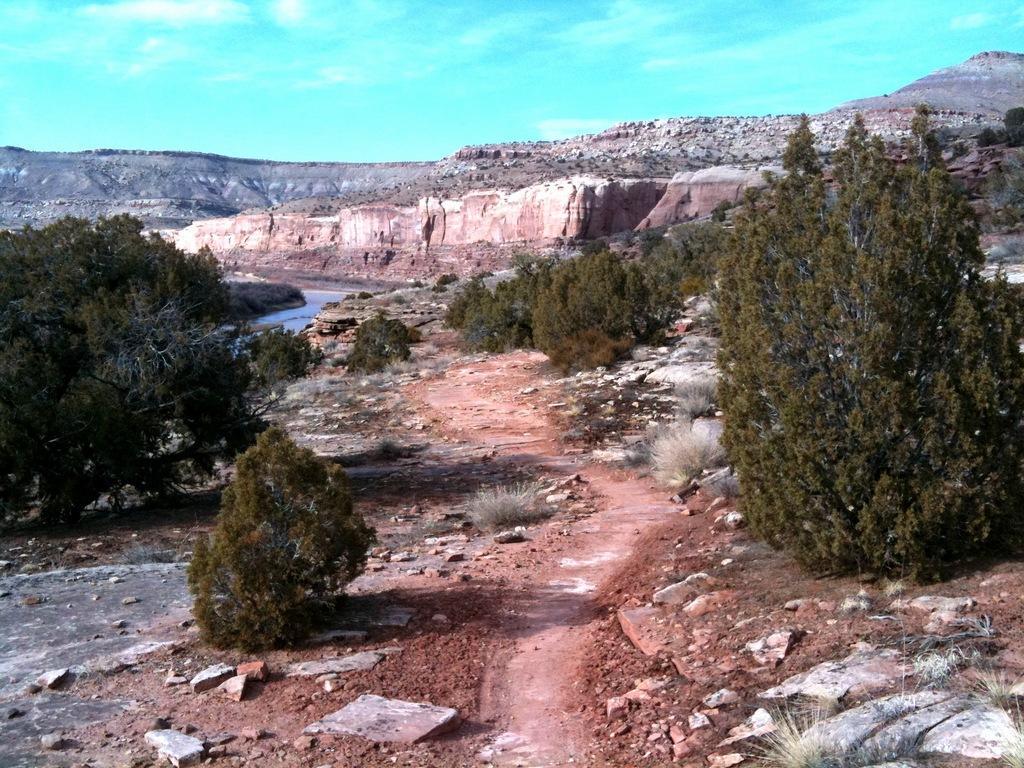Can you describe this image briefly? To the bottom of the image to the left side there is a grass, stones and trees are on the ground and also there is a mud. To the right corner of the image there are stones, trees and also there is a grass on the ground. In the background there is water on the ground and also there are trees, heels with stones. And to the top of the image there is a sky. 